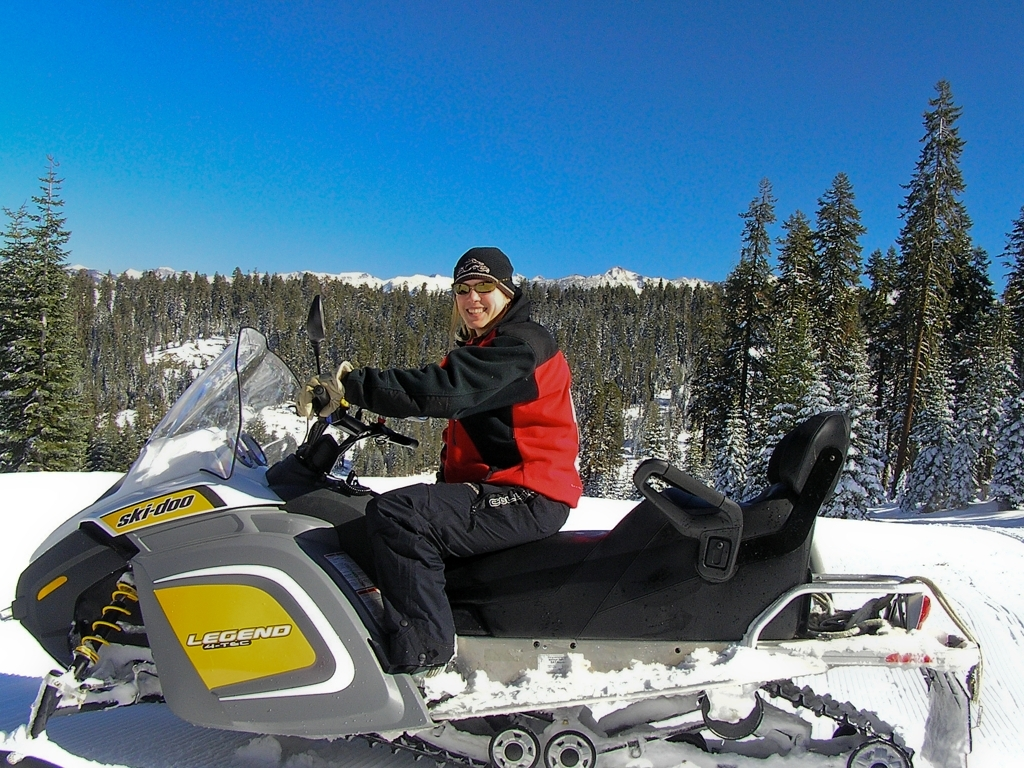What time of day does it seem to be in the image? Considering the brightness of the surroundings and the shadows cast on the snow, it appears to be a sunny day with the sun at a higher position in the sky, which likely indicates late morning or early afternoon. The clear blue sky also suggests favorable weather conditions for outdoor snow activities. 